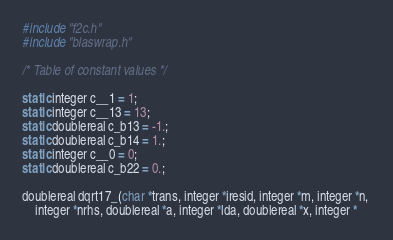<code> <loc_0><loc_0><loc_500><loc_500><_C_>#include "f2c.h"
#include "blaswrap.h"

/* Table of constant values */

static integer c__1 = 1;
static integer c__13 = 13;
static doublereal c_b13 = -1.;
static doublereal c_b14 = 1.;
static integer c__0 = 0;
static doublereal c_b22 = 0.;

doublereal dqrt17_(char *trans, integer *iresid, integer *m, integer *n, 
	integer *nrhs, doublereal *a, integer *lda, doublereal *x, integer *</code> 